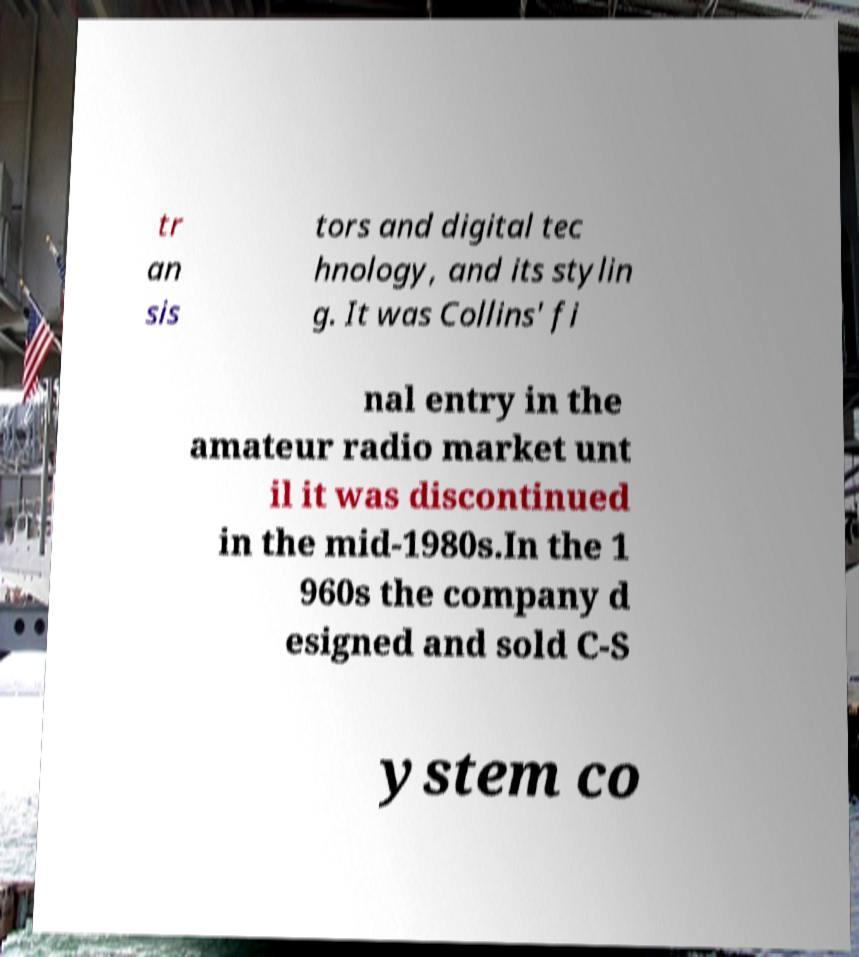Can you read and provide the text displayed in the image?This photo seems to have some interesting text. Can you extract and type it out for me? tr an sis tors and digital tec hnology, and its stylin g. It was Collins' fi nal entry in the amateur radio market unt il it was discontinued in the mid-1980s.In the 1 960s the company d esigned and sold C-S ystem co 